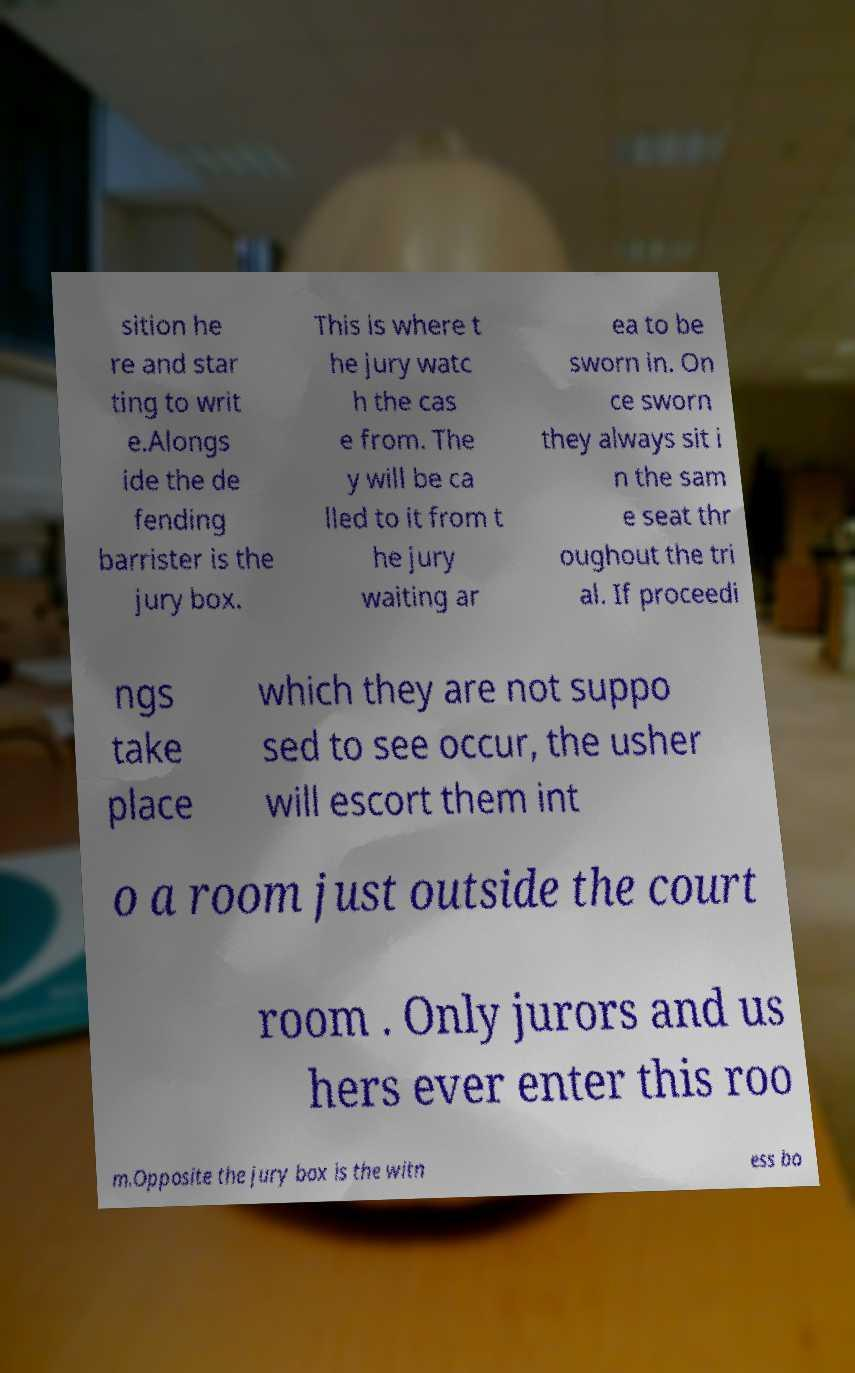Can you read and provide the text displayed in the image?This photo seems to have some interesting text. Can you extract and type it out for me? sition he re and star ting to writ e.Alongs ide the de fending barrister is the jury box. This is where t he jury watc h the cas e from. The y will be ca lled to it from t he jury waiting ar ea to be sworn in. On ce sworn they always sit i n the sam e seat thr oughout the tri al. If proceedi ngs take place which they are not suppo sed to see occur, the usher will escort them int o a room just outside the court room . Only jurors and us hers ever enter this roo m.Opposite the jury box is the witn ess bo 